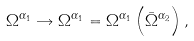<formula> <loc_0><loc_0><loc_500><loc_500>\Omega ^ { \alpha _ { 1 } } \rightarrow \Omega ^ { \alpha _ { 1 } } = \Omega ^ { \alpha _ { 1 } } \left ( \bar { \Omega } ^ { \alpha _ { 2 } } \right ) ,</formula> 